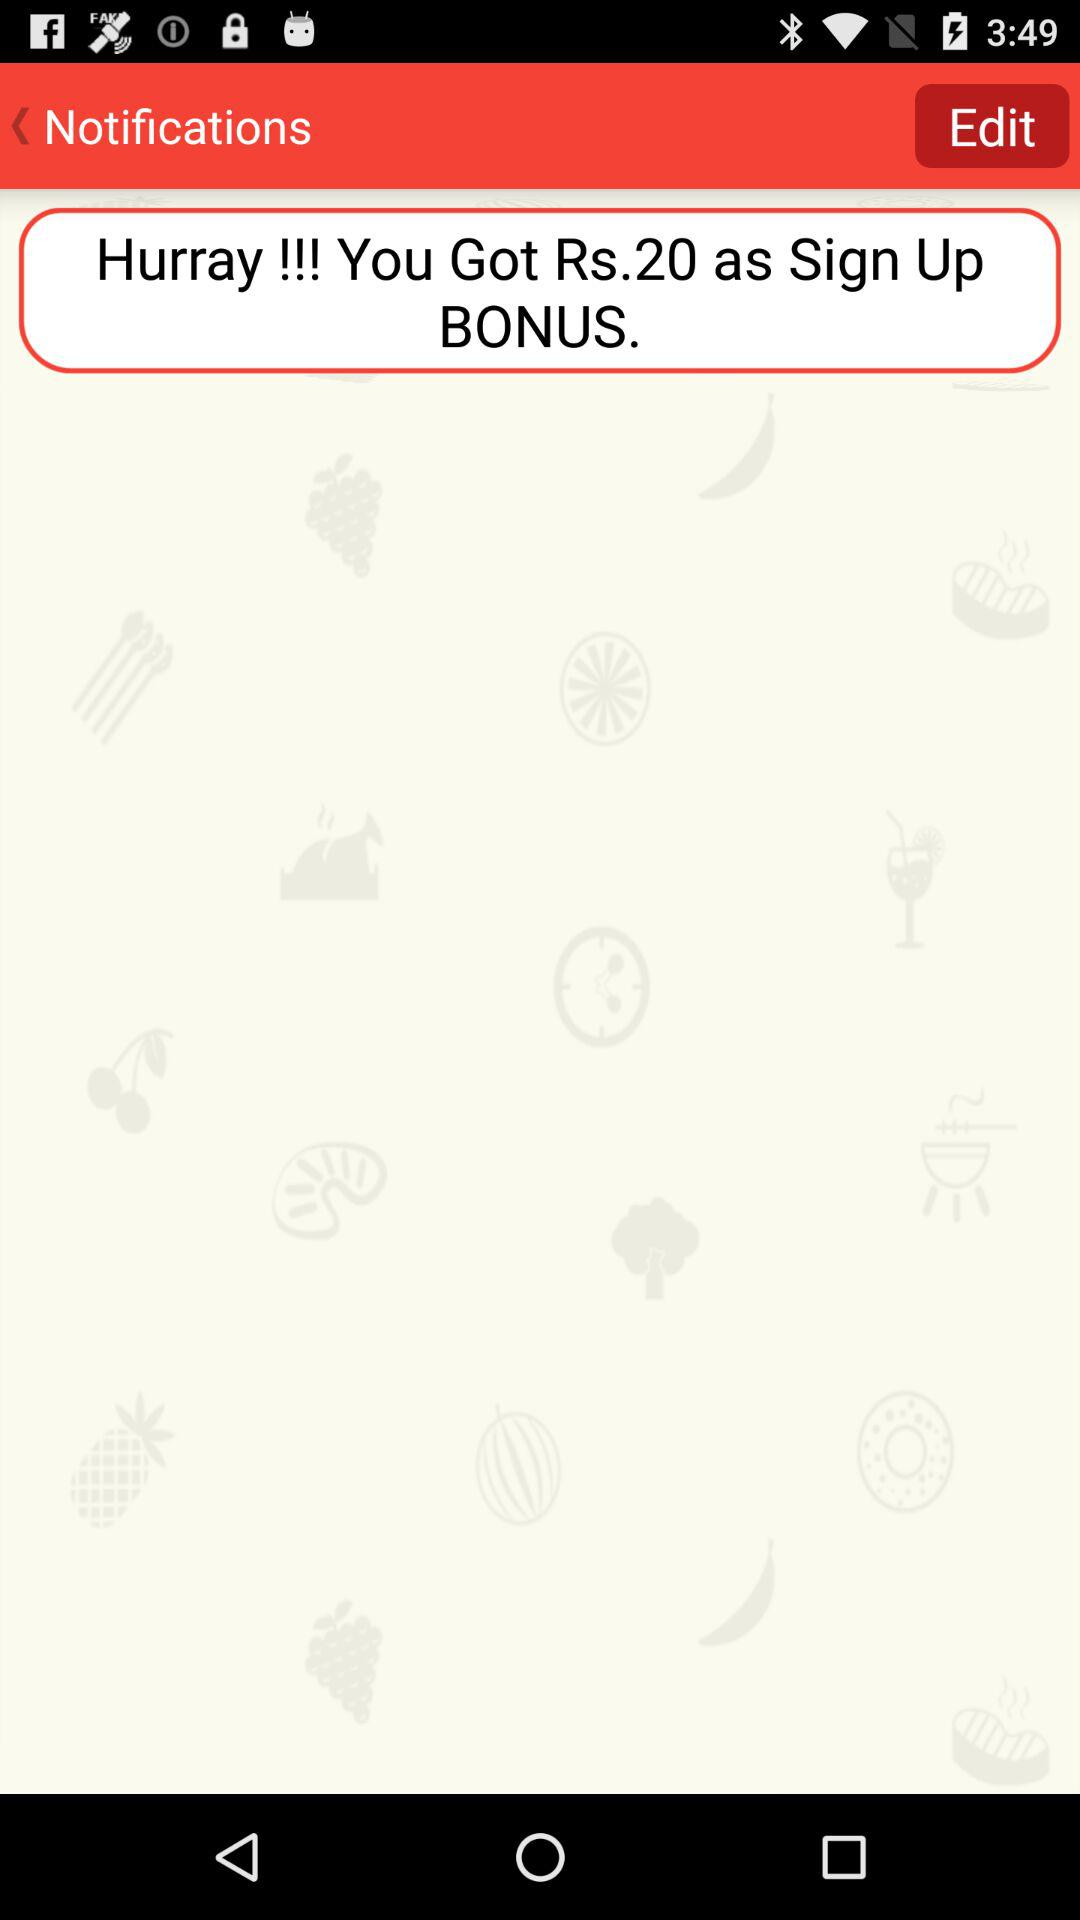How much is the sign-up bonus in U.S. dollars?
When the provided information is insufficient, respond with <no answer>. <no answer> 